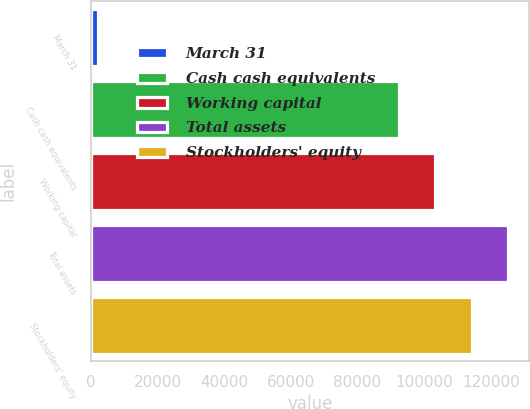Convert chart. <chart><loc_0><loc_0><loc_500><loc_500><bar_chart><fcel>March 31<fcel>Cash cash equivalents<fcel>Working capital<fcel>Total assets<fcel>Stockholders' equity<nl><fcel>2001<fcel>92498<fcel>103394<fcel>125186<fcel>114290<nl></chart> 